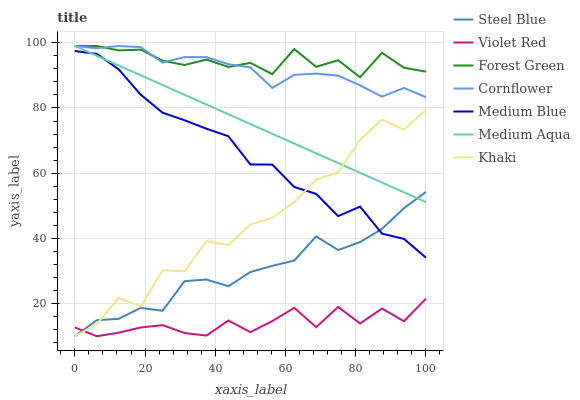Does Khaki have the minimum area under the curve?
Answer yes or no. No. Does Khaki have the maximum area under the curve?
Answer yes or no. No. Is Violet Red the smoothest?
Answer yes or no. No. Is Violet Red the roughest?
Answer yes or no. No. Does Medium Blue have the lowest value?
Answer yes or no. No. Does Khaki have the highest value?
Answer yes or no. No. Is Violet Red less than Forest Green?
Answer yes or no. Yes. Is Medium Aqua greater than Violet Red?
Answer yes or no. Yes. Does Violet Red intersect Forest Green?
Answer yes or no. No. 